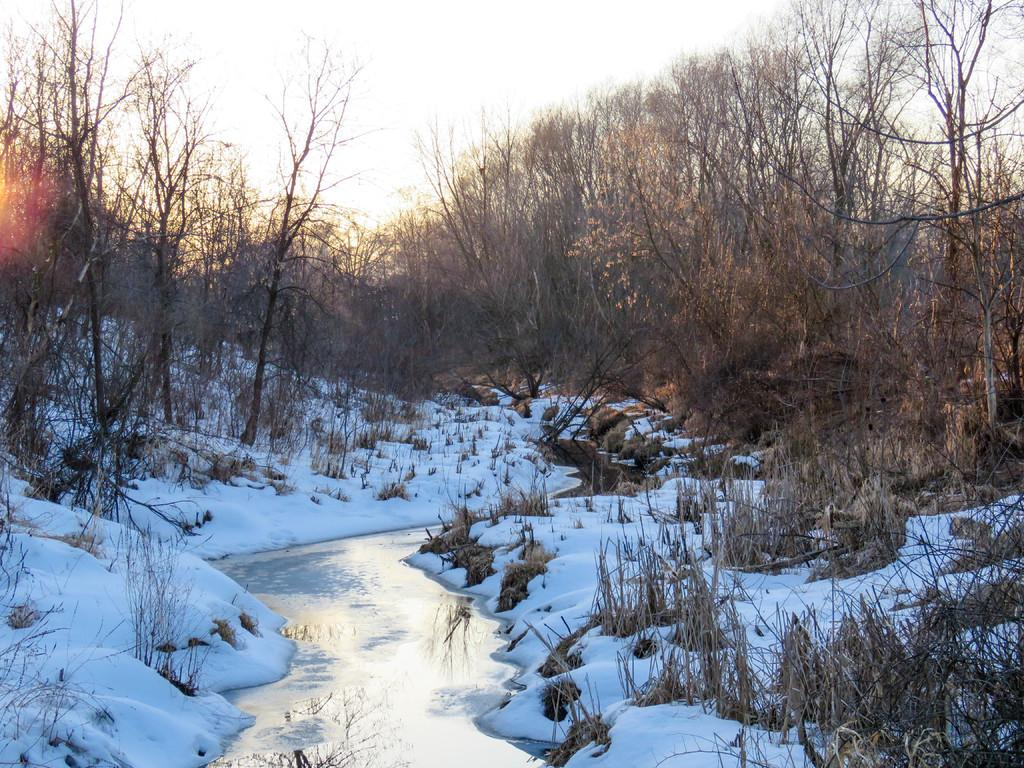What is the main feature in the center of the image? There is water in the center of the image. What type of weather condition is depicted in the image? There is snow visible in the image, indicating a cold or wintry environment. What type of vegetation can be seen in the image? There are plants and trees in the image. What is visible in the background of the image? The sky is visible in the background of the image. What type of humor can be seen in the image? There is no humor depicted in the image; it features water, snow, plants, trees, and the sky. Can you compare the size of the trees in the image to the size of the plants? While the image shows both trees and plants, it does not provide a clear comparison of their sizes. 